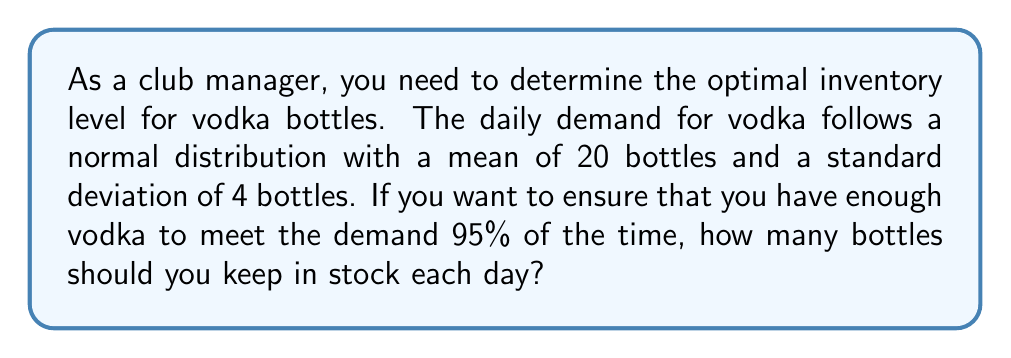Show me your answer to this math problem. To solve this problem, we'll use the properties of the normal distribution and the concept of z-scores.

Step 1: Identify the given information
- Daily demand follows a normal distribution
- Mean (μ) = 20 bottles
- Standard deviation (σ) = 4 bottles
- Desired service level = 95%

Step 2: Find the z-score for 95% confidence
For 95% confidence, we need the z-score that leaves 5% in the upper tail.
From a standard normal table or calculator, we find that z = 1.645 for 95% confidence.

Step 3: Use the z-score formula to calculate the required inventory level
The formula is:
$$X = μ + z * σ$$
Where:
X = required inventory level
μ = mean demand
z = z-score for desired confidence level
σ = standard deviation of demand

Plugging in the values:
$$X = 20 + 1.645 * 4$$
$$X = 20 + 6.58$$
$$X = 26.58$$

Step 4: Round up to the nearest whole number
Since we can't stock partial bottles, we round up to 27 bottles.
Answer: 27 bottles 